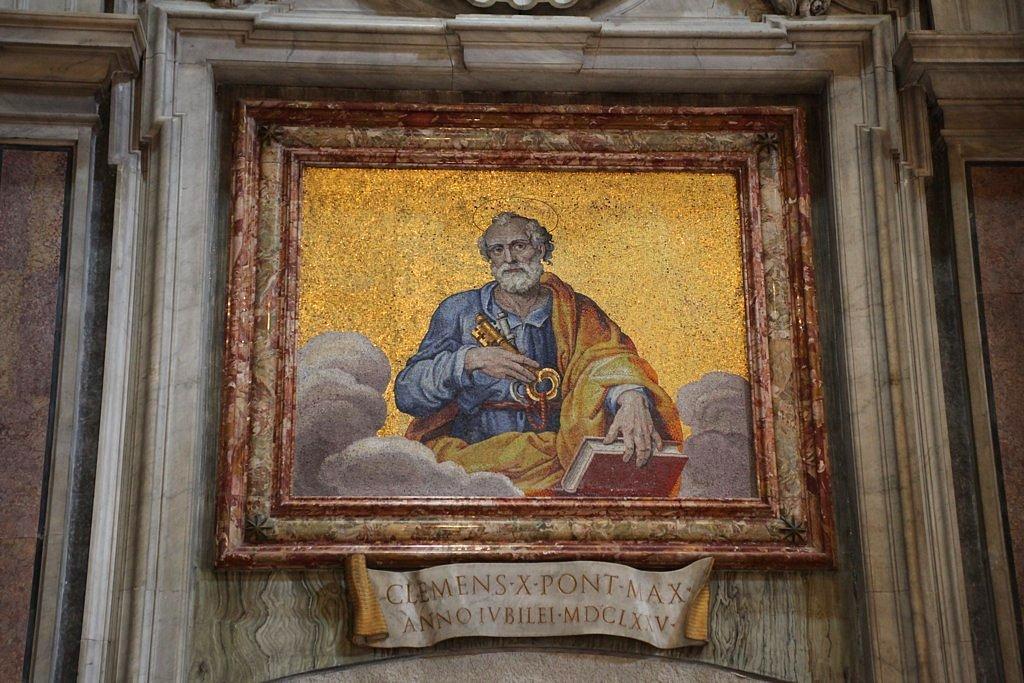In one or two sentences, can you explain what this image depicts? In this image I can see a photo frame on the wall. 